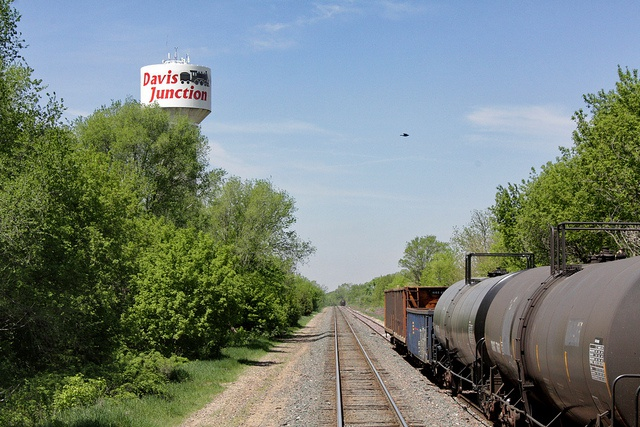Describe the objects in this image and their specific colors. I can see train in gray and black tones and bird in gray, black, and darkblue tones in this image. 